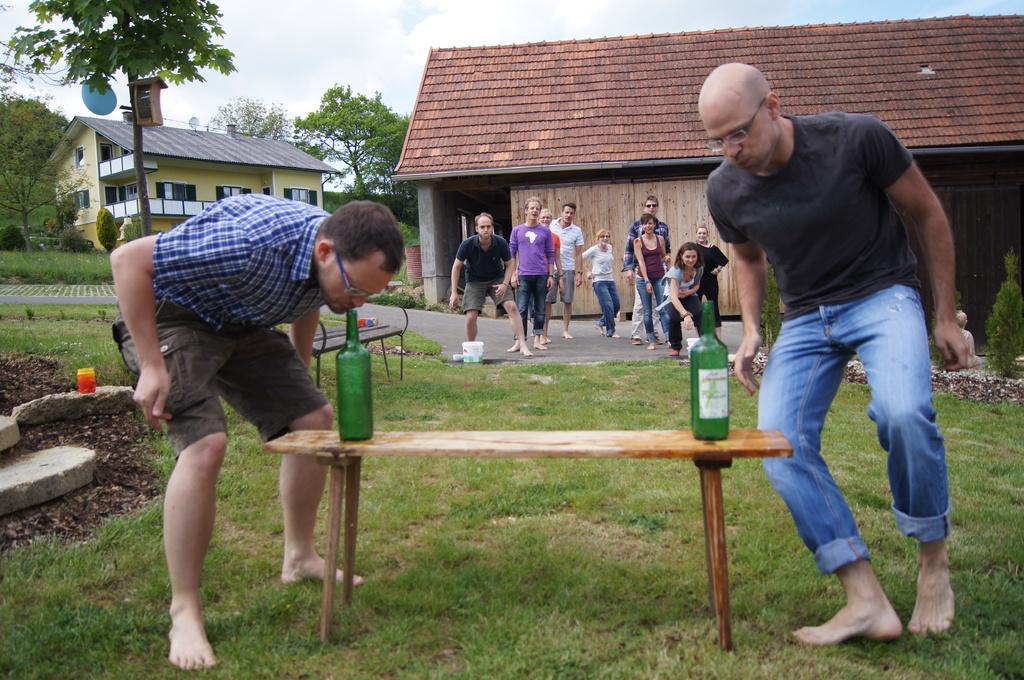Describe this image in one or two sentences. This picture is of outside. On the right there is a man wearing black color t-shirts and standing. On the left there is a man wearing blue color shirt and standing. In the center there is a table on the top of which two bottles are placed. In the background we can see group of people standing, a house, trees, a pole and the sky. 